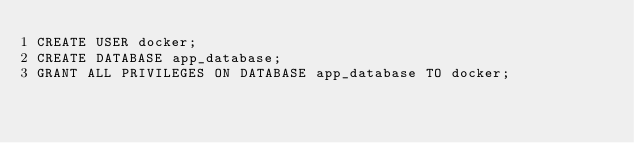<code> <loc_0><loc_0><loc_500><loc_500><_SQL_>CREATE USER docker;
CREATE DATABASE app_database;
GRANT ALL PRIVILEGES ON DATABASE app_database TO docker;
</code> 